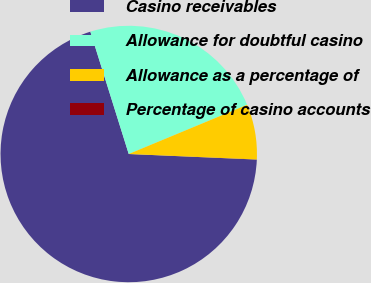Convert chart. <chart><loc_0><loc_0><loc_500><loc_500><pie_chart><fcel>Casino receivables<fcel>Allowance for doubtful casino<fcel>Allowance as a percentage of<fcel>Percentage of casino accounts<nl><fcel>69.47%<fcel>23.57%<fcel>6.95%<fcel>0.01%<nl></chart> 